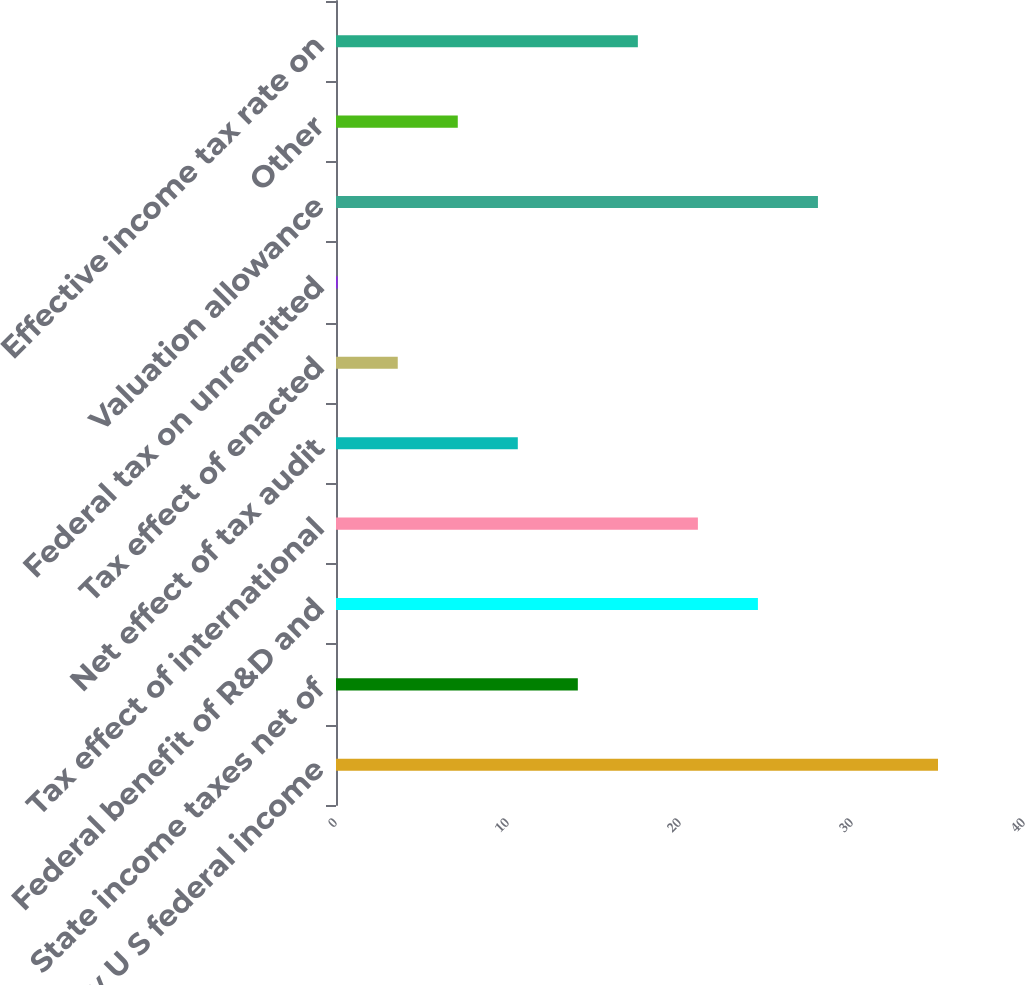Convert chart to OTSL. <chart><loc_0><loc_0><loc_500><loc_500><bar_chart><fcel>Statutory U S federal income<fcel>State income taxes net of<fcel>Federal benefit of R&D and<fcel>Tax effect of international<fcel>Net effect of tax audit<fcel>Tax effect of enacted<fcel>Federal tax on unremitted<fcel>Valuation allowance<fcel>Other<fcel>Effective income tax rate on<nl><fcel>35<fcel>14.06<fcel>24.53<fcel>21.04<fcel>10.57<fcel>3.59<fcel>0.1<fcel>28.02<fcel>7.08<fcel>17.55<nl></chart> 